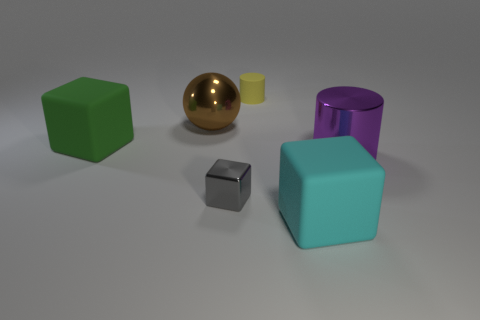There is a cylinder left of the large rubber block to the right of the green object; what is its size?
Offer a terse response. Small. How many tiny objects are blue matte cylinders or green rubber things?
Provide a succinct answer. 0. Is the number of rubber cylinders less than the number of cubes?
Provide a succinct answer. Yes. Are there more tiny yellow things than rubber objects?
Your answer should be very brief. No. How many other things are the same color as the tiny matte object?
Provide a succinct answer. 0. There is a large object behind the large green thing; what number of big rubber cubes are behind it?
Your response must be concise. 0. There is a large brown metallic thing; are there any rubber cylinders behind it?
Make the answer very short. Yes. There is a large rubber thing that is in front of the big cube left of the tiny gray metal thing; what is its shape?
Keep it short and to the point. Cube. Are there fewer metallic objects that are right of the big green cube than cyan rubber things that are in front of the large cyan rubber cube?
Your answer should be compact. No. There is another object that is the same shape as the purple thing; what is its color?
Keep it short and to the point. Yellow. 